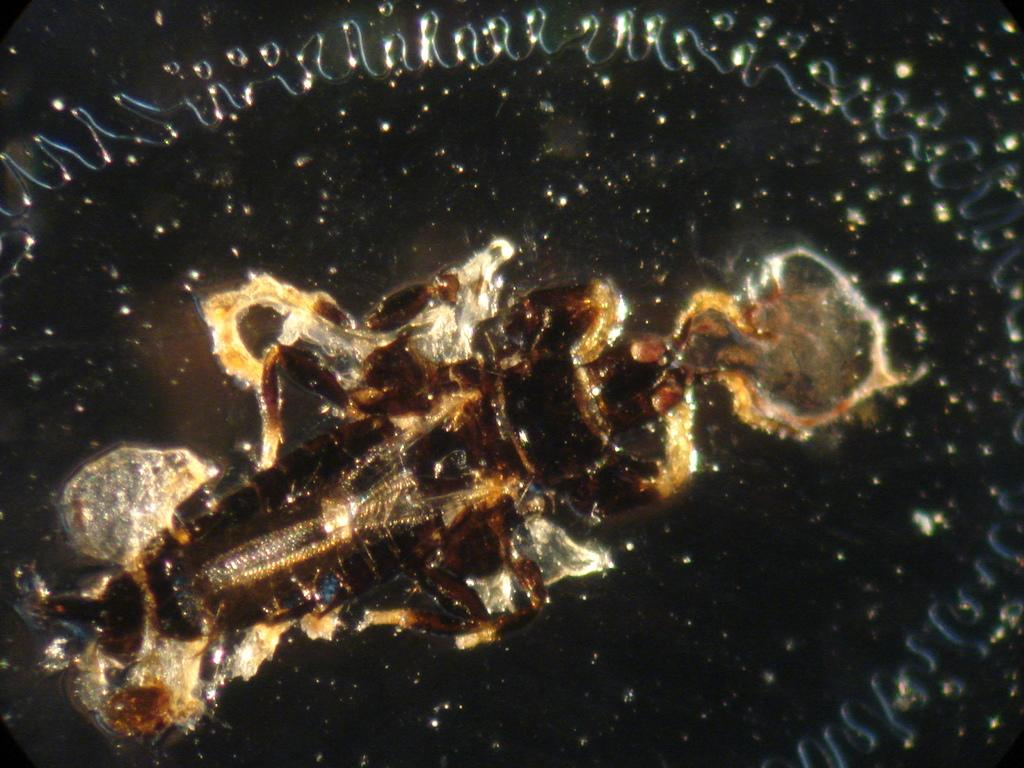What can be observed about the objects in the image? The objects in the image are colorful and thrown in the water. Can you describe the appearance of the objects? The objects are colorful, but their specific shapes or designs cannot be determined from the provided facts. What is the value of the wheel in the image? There is no wheel present in the image, so it is not possible to determine its value. 